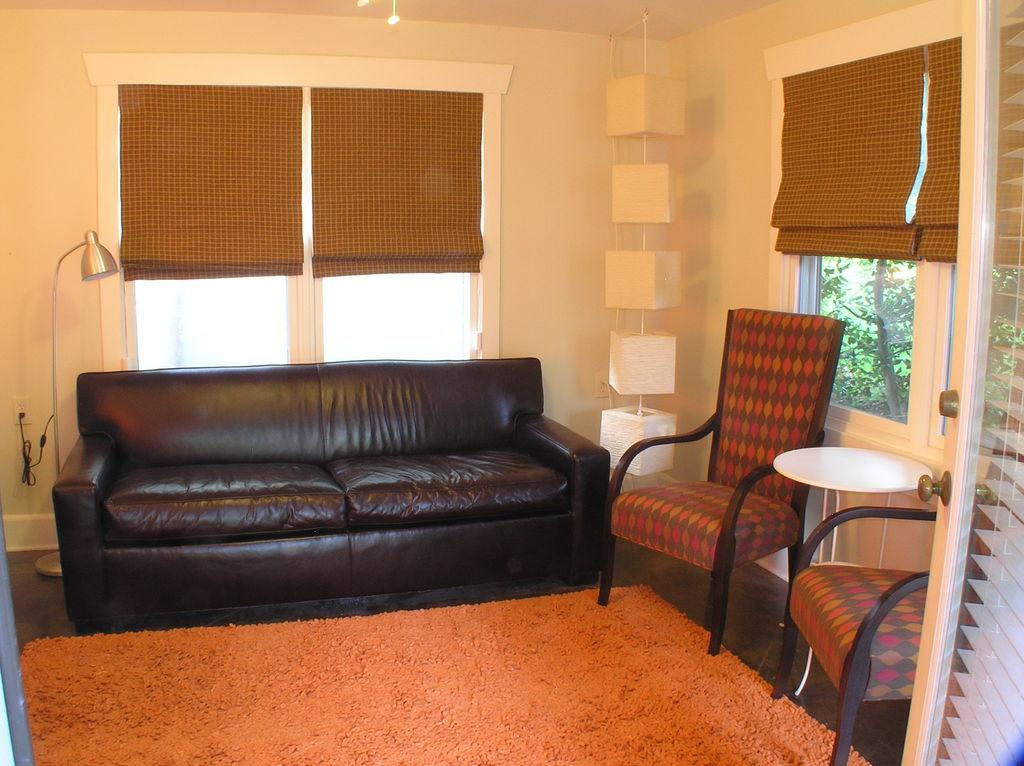What type of furniture is present in the image? There is a sofa and chairs in the image. What type of lighting is present in the image? There is a lamp in the image. What type of surface is present in the image? There is a table in the image. What type of architectural feature is present in the image? There are glass windows in the image. What type of window treatment is present in the image? There are window blinds in the image. What flavor of book can be seen on the table in the image? There is no book present in the image, and therefore no flavor can be associated with it. 